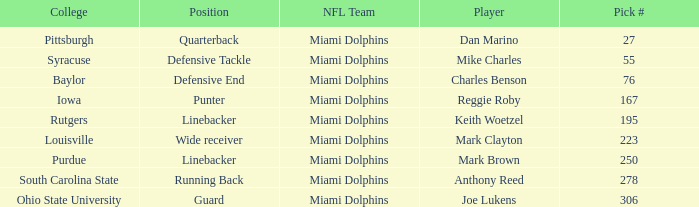If the Position is Running Back what is the Total number of Pick #? 1.0. 